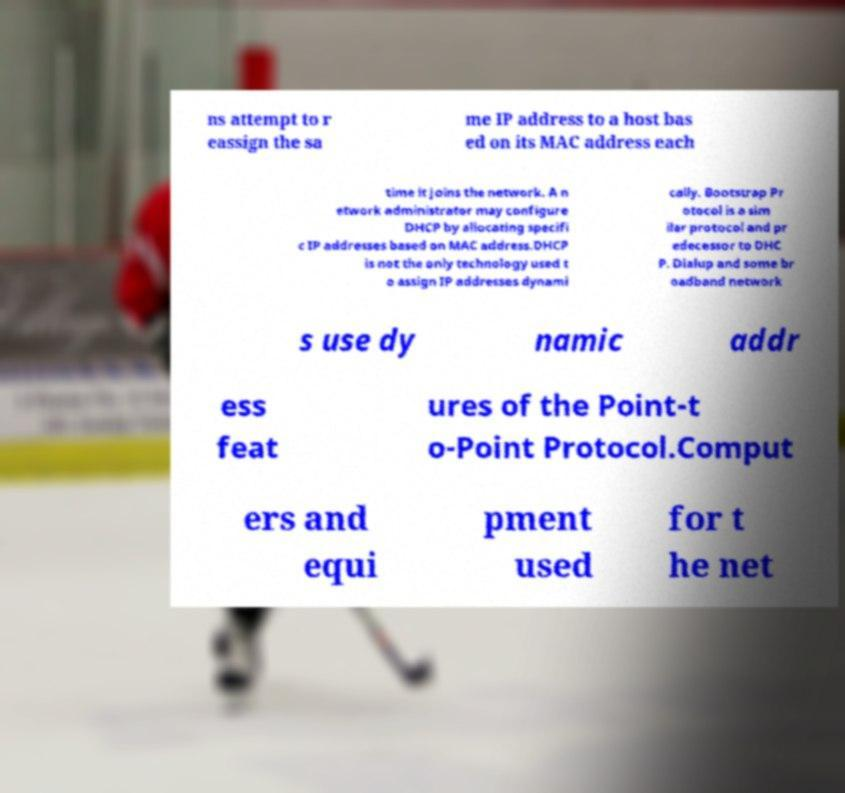Can you read and provide the text displayed in the image?This photo seems to have some interesting text. Can you extract and type it out for me? ns attempt to r eassign the sa me IP address to a host bas ed on its MAC address each time it joins the network. A n etwork administrator may configure DHCP by allocating specifi c IP addresses based on MAC address.DHCP is not the only technology used t o assign IP addresses dynami cally. Bootstrap Pr otocol is a sim ilar protocol and pr edecessor to DHC P. Dialup and some br oadband network s use dy namic addr ess feat ures of the Point-t o-Point Protocol.Comput ers and equi pment used for t he net 